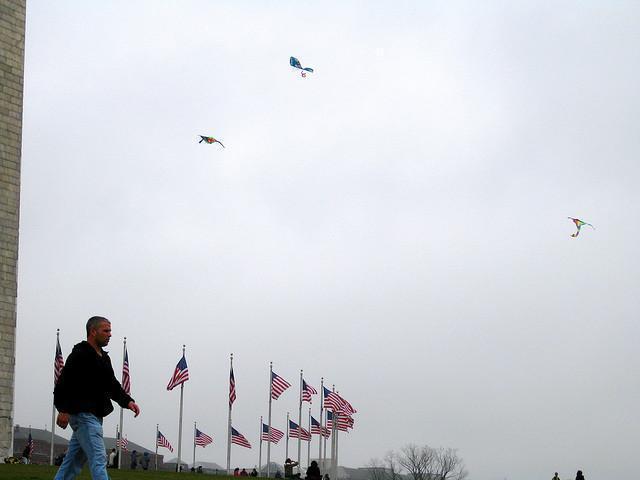How many copies of the same guy are in the picture?
Give a very brief answer. 1. How many people are visible?
Give a very brief answer. 1. How many street lights are on the right?
Give a very brief answer. 0. 